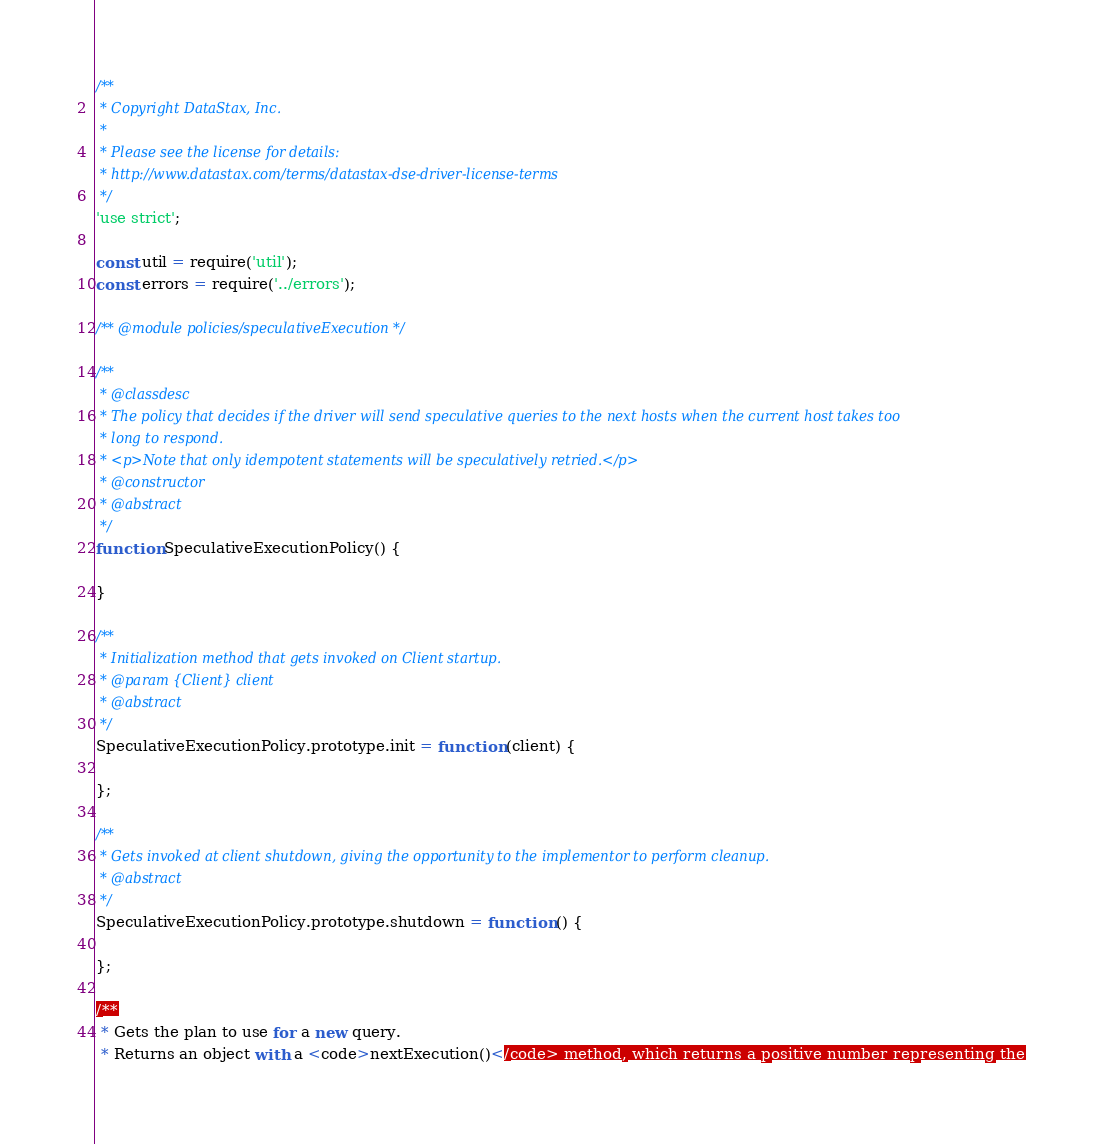Convert code to text. <code><loc_0><loc_0><loc_500><loc_500><_JavaScript_>/**
 * Copyright DataStax, Inc.
 *
 * Please see the license for details:
 * http://www.datastax.com/terms/datastax-dse-driver-license-terms
 */
'use strict';

const util = require('util');
const errors = require('../errors');

/** @module policies/speculativeExecution */

/**
 * @classdesc
 * The policy that decides if the driver will send speculative queries to the next hosts when the current host takes too
 * long to respond.
 * <p>Note that only idempotent statements will be speculatively retried.</p>
 * @constructor
 * @abstract
 */
function SpeculativeExecutionPolicy() {
  
}

/**
 * Initialization method that gets invoked on Client startup.
 * @param {Client} client
 * @abstract
 */
SpeculativeExecutionPolicy.prototype.init = function (client) {

};

/**
 * Gets invoked at client shutdown, giving the opportunity to the implementor to perform cleanup.
 * @abstract
 */
SpeculativeExecutionPolicy.prototype.shutdown = function () {

};

/**
 * Gets the plan to use for a new query.
 * Returns an object with a <code>nextExecution()</code> method, which returns a positive number representing the</code> 